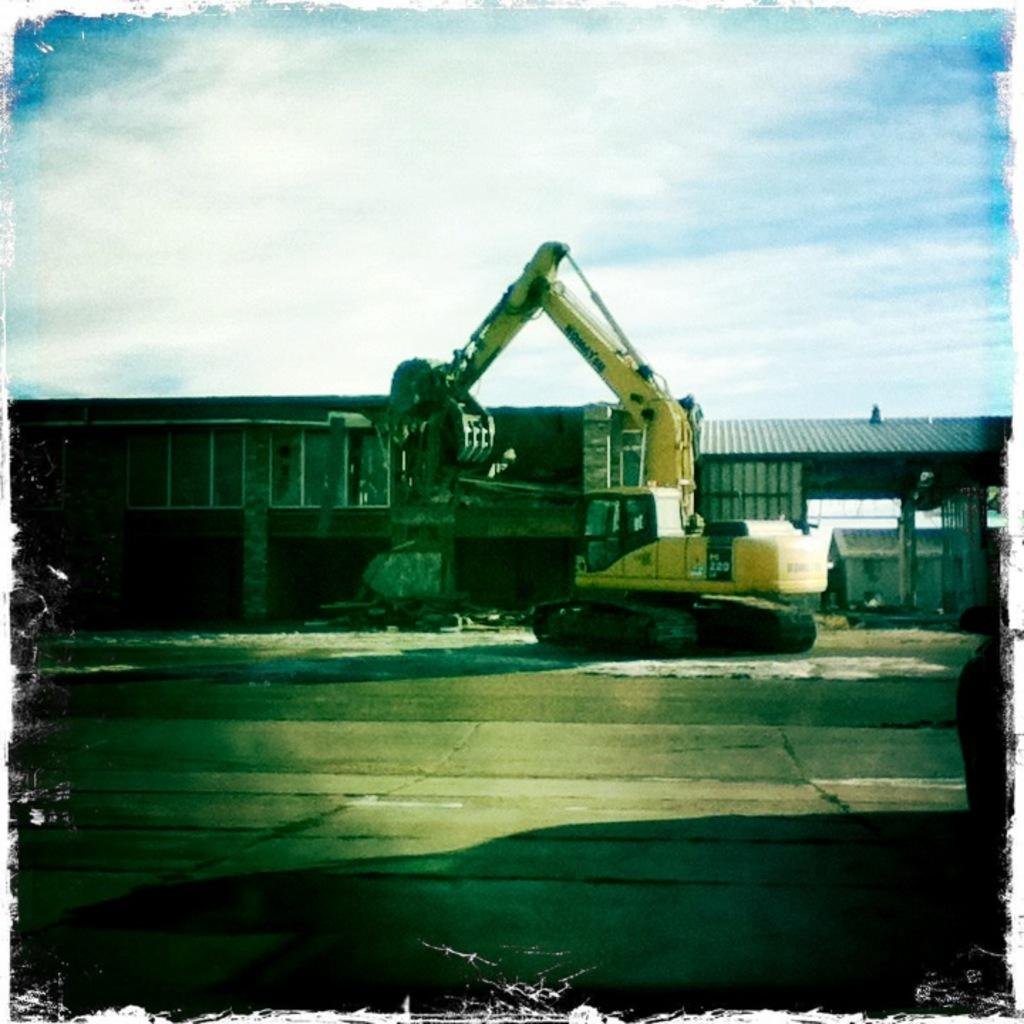What is the main subject of the picture? The main subject of the picture is a crane. What can be seen in the background of the picture? There are houses in the background of the picture. How would you describe the sky in the picture? The sky is blue and cloudy in the picture. What type of kitty can be seen playing with a shirt in the image? There is no kitty or shirt present in the image; it features a crane and houses in the background. 